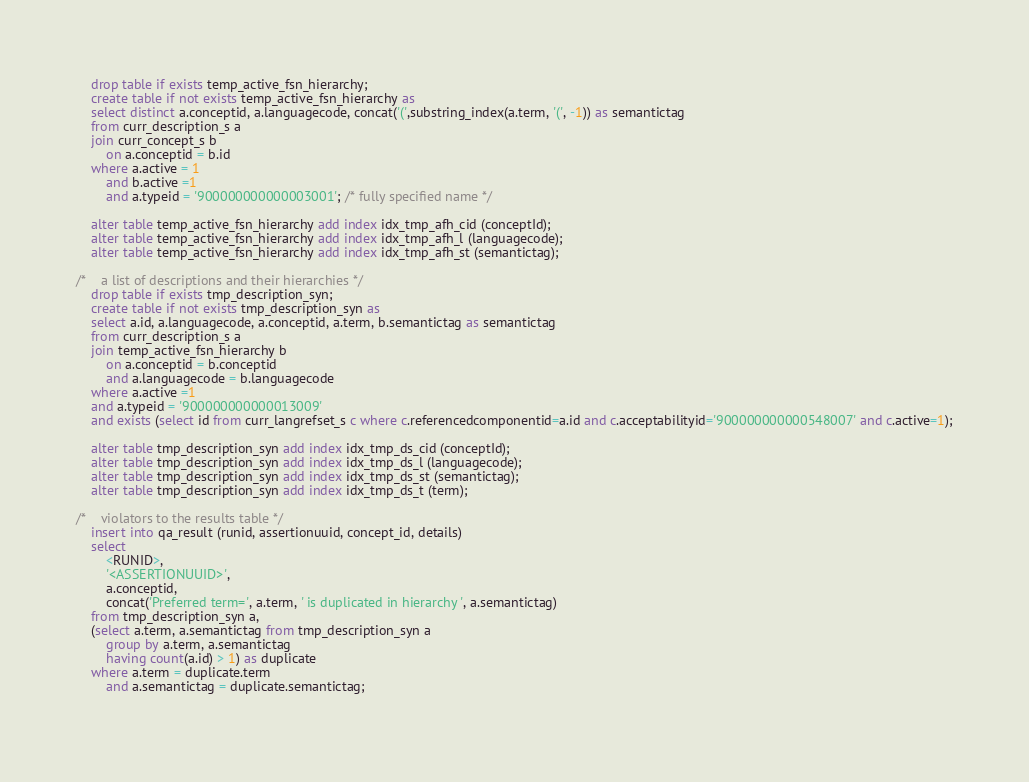<code> <loc_0><loc_0><loc_500><loc_500><_SQL_>
	drop table if exists temp_active_fsn_hierarchy;
	create table if not exists temp_active_fsn_hierarchy as
	select distinct a.conceptid, a.languagecode, concat('(',substring_index(a.term, '(', -1)) as semantictag
	from curr_description_s a
	join curr_concept_s b
		on a.conceptid = b.id
	where a.active = 1
		and b.active =1
		and a.typeid = '900000000000003001'; /* fully specified name */
		
	alter table temp_active_fsn_hierarchy add index idx_tmp_afh_cid (conceptId);
	alter table temp_active_fsn_hierarchy add index idx_tmp_afh_l (languagecode);
	alter table temp_active_fsn_hierarchy add index idx_tmp_afh_st (semantictag);

/* 	a list of descriptions and their hierarchies */
	drop table if exists tmp_description_syn;
	create table if not exists tmp_description_syn as 
	select a.id, a.languagecode, a.conceptid, a.term, b.semantictag as semantictag
	from curr_description_s a
	join temp_active_fsn_hierarchy b
		on a.conceptid = b.conceptid
		and a.languagecode = b.languagecode
	where a.active =1
	and a.typeid = '900000000000013009'
	and exists (select id from curr_langrefset_s c where c.referencedcomponentid=a.id and c.acceptabilityid='900000000000548007' and c.active=1);

	alter table tmp_description_syn add index idx_tmp_ds_cid (conceptId);
	alter table tmp_description_syn add index idx_tmp_ds_l (languagecode);
	alter table tmp_description_syn add index idx_tmp_ds_st (semantictag);
	alter table tmp_description_syn add index idx_tmp_ds_t (term);

/* 	violators to the results table */	
	insert into qa_result (runid, assertionuuid, concept_id, details)
	select 
		<RUNID>,
		'<ASSERTIONUUID>',
		a.conceptid,
		concat('Preferred term=', a.term, ' is duplicated in hierarchy ', a.semantictag)
	from tmp_description_syn a,
	(select a.term, a.semantictag from tmp_description_syn a 
		group by a.term, a.semantictag
		having count(a.id) > 1) as duplicate
	where a.term = duplicate.term
		and a.semantictag = duplicate.semantictag;
	</code> 